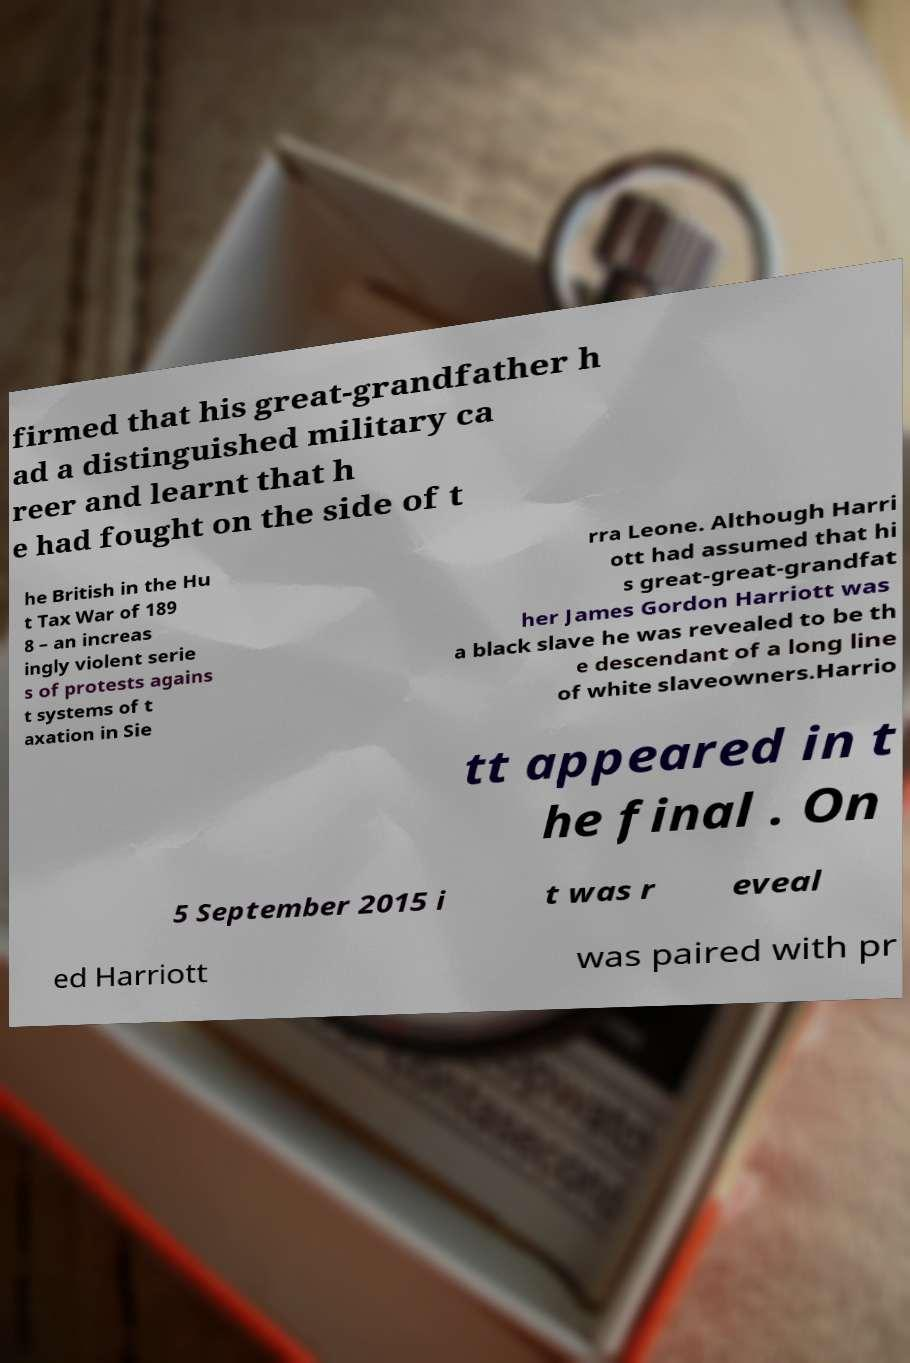Could you extract and type out the text from this image? firmed that his great-grandfather h ad a distinguished military ca reer and learnt that h e had fought on the side of t he British in the Hu t Tax War of 189 8 – an increas ingly violent serie s of protests agains t systems of t axation in Sie rra Leone. Although Harri ott had assumed that hi s great-great-grandfat her James Gordon Harriott was a black slave he was revealed to be th e descendant of a long line of white slaveowners.Harrio tt appeared in t he final . On 5 September 2015 i t was r eveal ed Harriott was paired with pr 